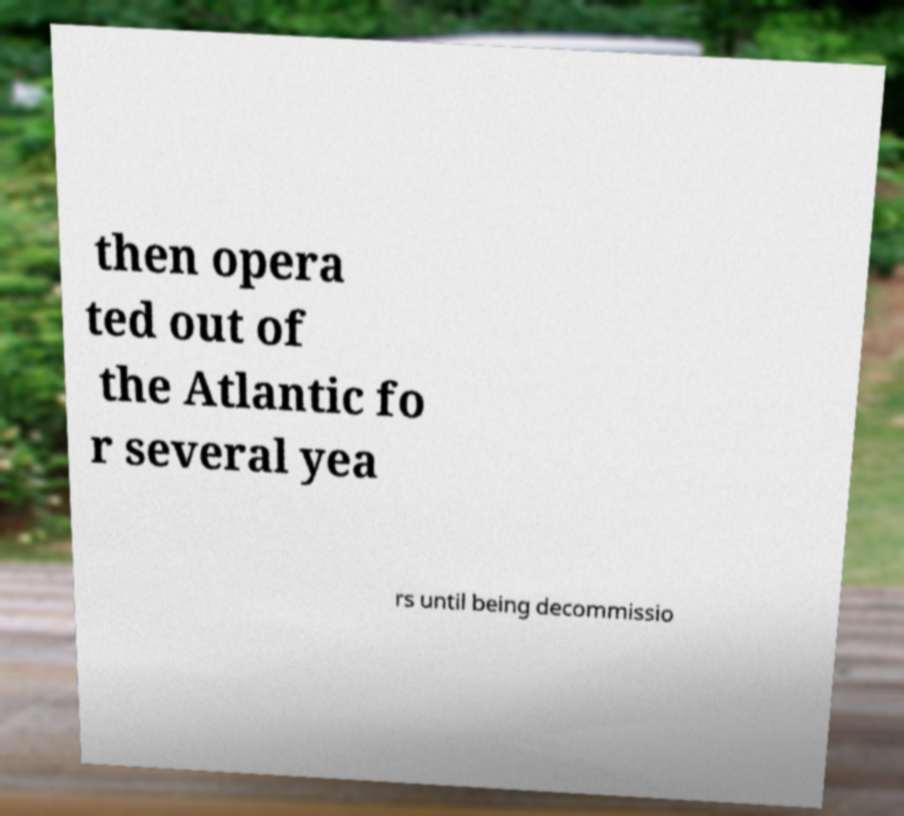Please identify and transcribe the text found in this image. then opera ted out of the Atlantic fo r several yea rs until being decommissio 